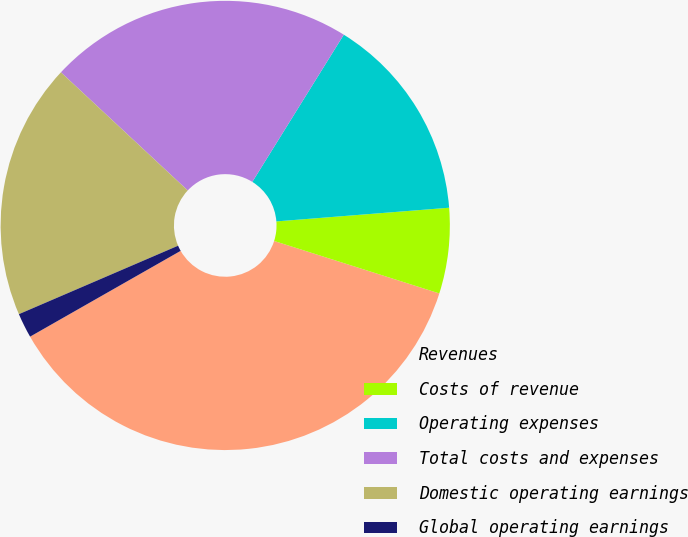Convert chart. <chart><loc_0><loc_0><loc_500><loc_500><pie_chart><fcel>Revenues<fcel>Costs of revenue<fcel>Operating expenses<fcel>Total costs and expenses<fcel>Domestic operating earnings<fcel>Global operating earnings<nl><fcel>36.86%<fcel>6.15%<fcel>14.89%<fcel>21.91%<fcel>18.4%<fcel>1.78%<nl></chart> 